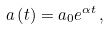<formula> <loc_0><loc_0><loc_500><loc_500>a \left ( t \right ) = a _ { 0 } e ^ { \alpha t } \, ,</formula> 